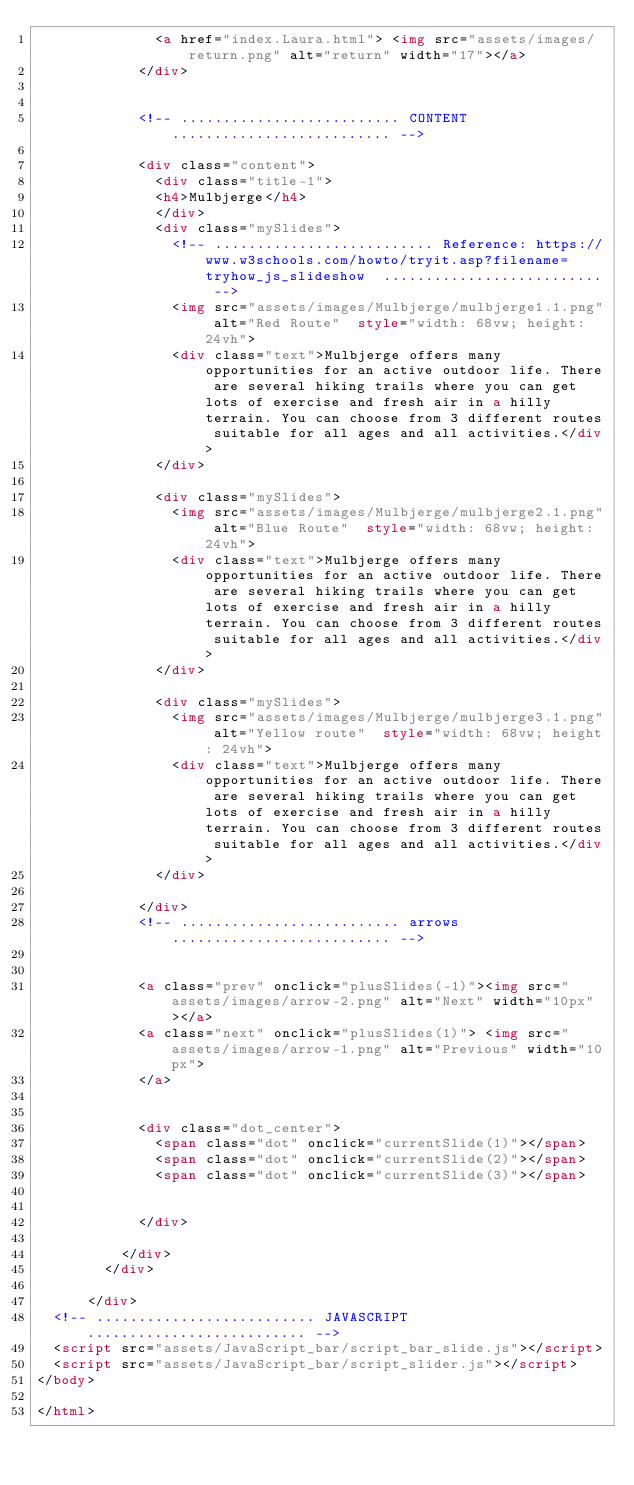Convert code to text. <code><loc_0><loc_0><loc_500><loc_500><_HTML_>              <a href="index.Laura.html"> <img src="assets/images/return.png" alt="return" width="17"></a>
            </div>


            <!-- .......................... CONTENT.......................... -->

            <div class="content">
              <div class="title-1">
              <h4>Mulbjerge</h4>
              </div>
              <div class="mySlides">
                <!-- .......................... Reference: https://www.w3schools.com/howto/tryit.asp?filename=tryhow_js_slideshow  .......................... -->
                <img src="assets/images/Mulbjerge/mulbjerge1.1.png" alt="Red Route"  style="width: 68vw; height: 24vh">
                <div class="text">Mulbjerge offers many opportunities for an active outdoor life. There are several hiking trails where you can get lots of exercise and fresh air in a hilly terrain. You can choose from 3 different routes suitable for all ages and all activities.</div>
              </div>

              <div class="mySlides">
                <img src="assets/images/Mulbjerge/mulbjerge2.1.png" alt="Blue Route"  style="width: 68vw; height: 24vh">
                <div class="text">Mulbjerge offers many opportunities for an active outdoor life. There are several hiking trails where you can get lots of exercise and fresh air in a hilly terrain. You can choose from 3 different routes suitable for all ages and all activities.</div>
              </div>

              <div class="mySlides">
                <img src="assets/images/Mulbjerge/mulbjerge3.1.png" alt="Yellow route"  style="width: 68vw; height: 24vh">
                <div class="text">Mulbjerge offers many opportunities for an active outdoor life. There are several hiking trails where you can get lots of exercise and fresh air in a hilly terrain. You can choose from 3 different routes suitable for all ages and all activities.</div>
              </div>

            </div>
            <!-- .......................... arrows .......................... -->


            <a class="prev" onclick="plusSlides(-1)"><img src="assets/images/arrow-2.png" alt="Next" width="10px"></a>
            <a class="next" onclick="plusSlides(1)"> <img src="assets/images/arrow-1.png" alt="Previous" width="10px">
            </a>


            <div class="dot_center">
              <span class="dot" onclick="currentSlide(1)"></span>
              <span class="dot" onclick="currentSlide(2)"></span>
              <span class="dot" onclick="currentSlide(3)"></span>


            </div>

          </div>
        </div>

      </div>
  <!-- .......................... JAVASCRIPT .......................... -->
  <script src="assets/JavaScript_bar/script_bar_slide.js"></script>
  <script src="assets/JavaScript_bar/script_slider.js"></script>
</body>

</html></code> 